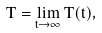<formula> <loc_0><loc_0><loc_500><loc_500>T = \lim _ { t \rightarrow \infty } T ( t ) ,</formula> 